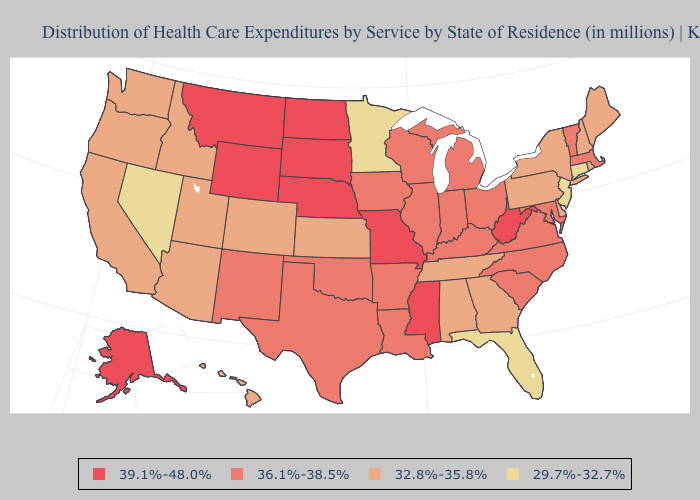Among the states that border Vermont , which have the lowest value?
Quick response, please. New Hampshire, New York. Which states hav the highest value in the MidWest?
Short answer required. Missouri, Nebraska, North Dakota, South Dakota. What is the highest value in states that border Vermont?
Concise answer only. 36.1%-38.5%. What is the lowest value in the Northeast?
Be succinct. 29.7%-32.7%. What is the value of Mississippi?
Concise answer only. 39.1%-48.0%. Name the states that have a value in the range 32.8%-35.8%?
Write a very short answer. Alabama, Arizona, California, Colorado, Delaware, Georgia, Hawaii, Idaho, Kansas, Maine, New Hampshire, New York, Oregon, Pennsylvania, Rhode Island, Tennessee, Utah, Washington. What is the value of Nevada?
Give a very brief answer. 29.7%-32.7%. Among the states that border Kentucky , does Ohio have the lowest value?
Keep it brief. No. What is the highest value in the West ?
Answer briefly. 39.1%-48.0%. Among the states that border Minnesota , which have the lowest value?
Keep it brief. Iowa, Wisconsin. What is the lowest value in the South?
Give a very brief answer. 29.7%-32.7%. What is the value of Florida?
Answer briefly. 29.7%-32.7%. Does the first symbol in the legend represent the smallest category?
Be succinct. No. What is the lowest value in states that border Idaho?
Concise answer only. 29.7%-32.7%. What is the value of Tennessee?
Short answer required. 32.8%-35.8%. 